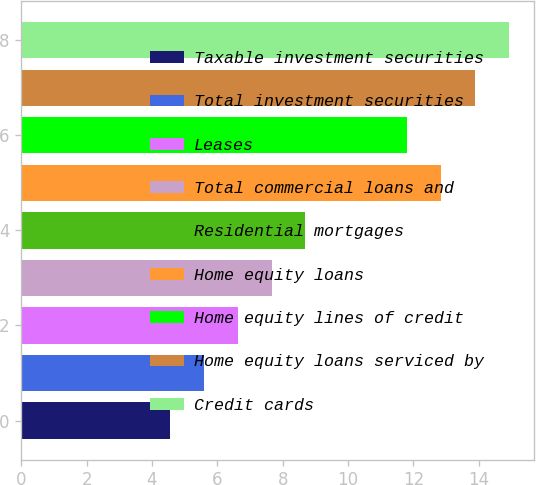Convert chart. <chart><loc_0><loc_0><loc_500><loc_500><bar_chart><fcel>Taxable investment securities<fcel>Total investment securities<fcel>Leases<fcel>Total commercial loans and<fcel>Residential mortgages<fcel>Home equity loans<fcel>Home equity lines of credit<fcel>Home equity loans serviced by<fcel>Credit cards<nl><fcel>4.54<fcel>5.58<fcel>6.62<fcel>7.66<fcel>8.7<fcel>12.86<fcel>11.82<fcel>13.9<fcel>14.94<nl></chart> 